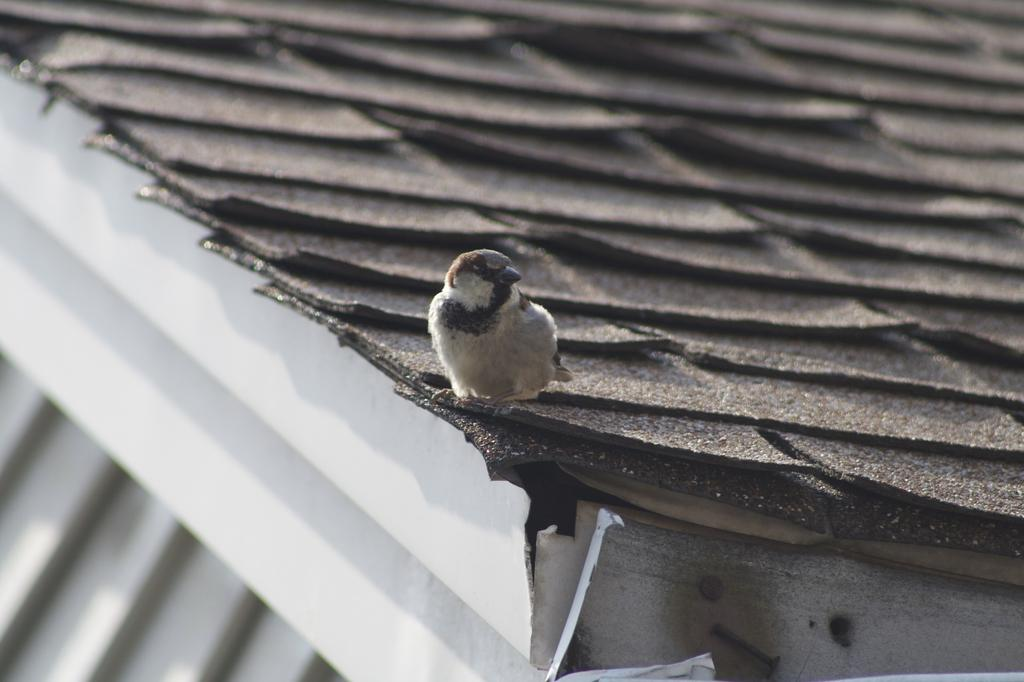What type of animal can be seen in the image? There is a bird in the image. Where is the bird located? The bird is on a building. What architectural feature is present in the image? There is a staircase in the image. What type of ornament is hanging from the bird's beak in the image? There is no ornament hanging from the bird's beak in the image. What color is the yarn that the bird is using to weave a basket in the image? There is no yarn or basket-weaving activity depicted in the image. 